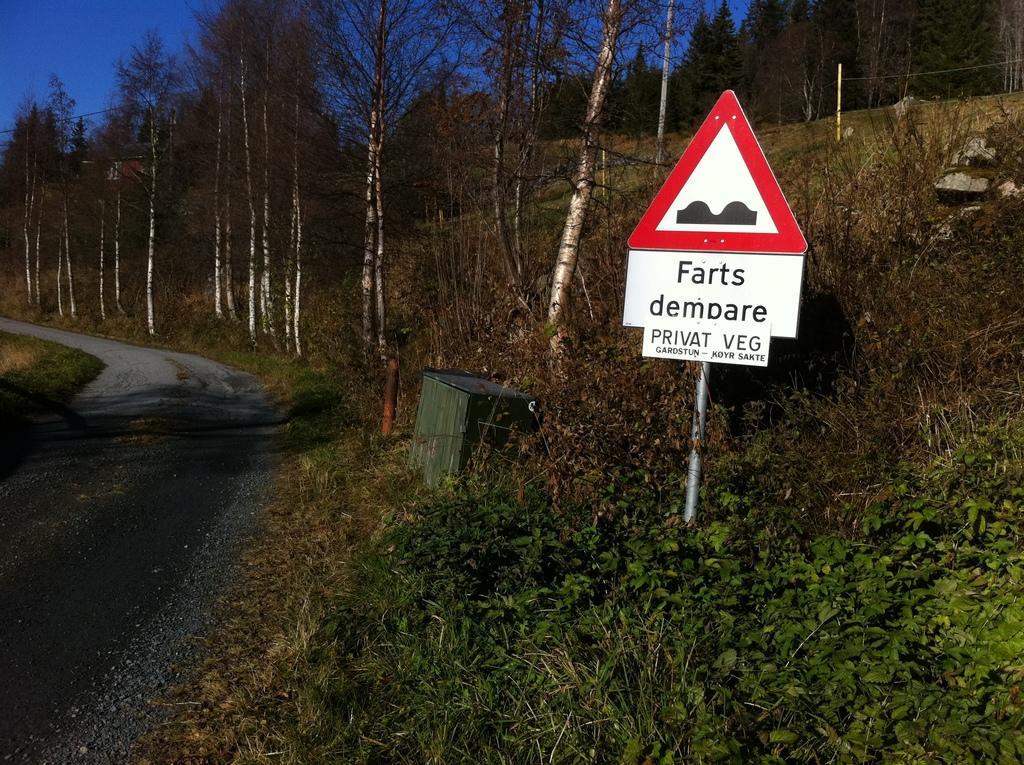How would you summarize this image in a sentence or two? In the picture I can see the road on the left side. There are trees on the side of the road. I can see a caution board pole on the side of the road on the right side. I can see a wooden block cabinet on the side of the road. I can see the blue sky. There are plants at the bottom of the picture. 